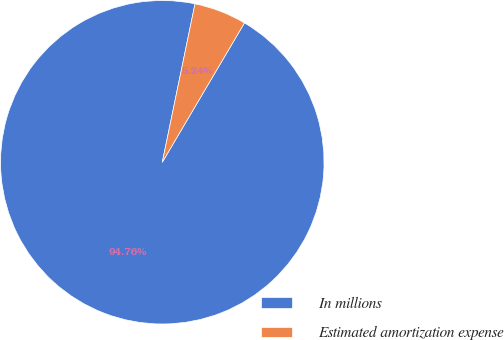Convert chart. <chart><loc_0><loc_0><loc_500><loc_500><pie_chart><fcel>In millions<fcel>Estimated amortization expense<nl><fcel>94.76%<fcel>5.24%<nl></chart> 